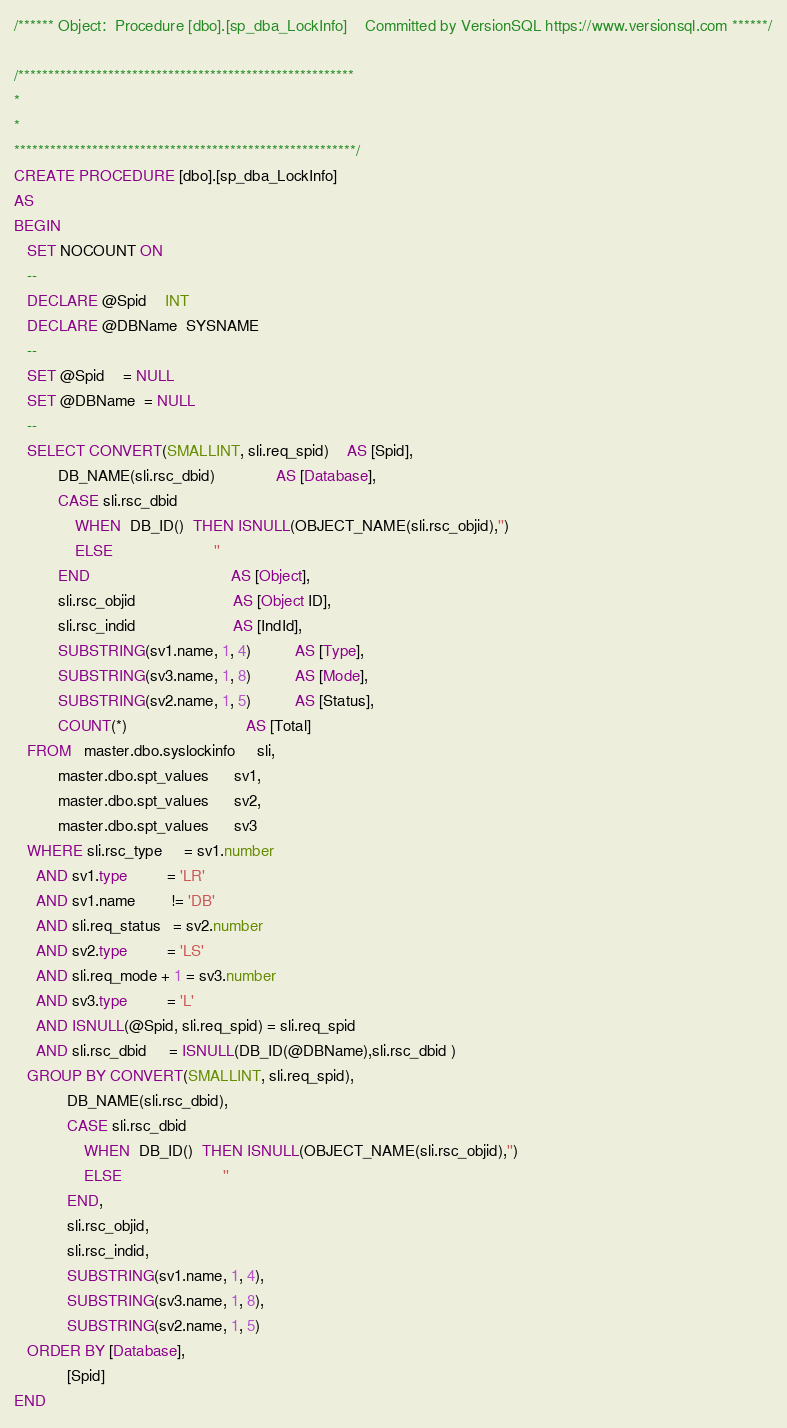Convert code to text. <code><loc_0><loc_0><loc_500><loc_500><_SQL_>/****** Object:  Procedure [dbo].[sp_dba_LockInfo]    Committed by VersionSQL https://www.versionsql.com ******/

/********************************************************
*
*
*********************************************************/
CREATE PROCEDURE [dbo].[sp_dba_LockInfo]
AS
BEGIN
   SET NOCOUNT ON
   --
   DECLARE @Spid    INT
   DECLARE @DBName  SYSNAME
   --
   SET @Spid    = NULL
   SET @DBName  = NULL
   -- 
   SELECT CONVERT(SMALLINT, sli.req_spid)    AS [Spid],
          DB_NAME(sli.rsc_dbid)              AS [Database],
          CASE sli.rsc_dbid
              WHEN  DB_ID()  THEN ISNULL(OBJECT_NAME(sli.rsc_objid),'')
              ELSE                       ''
          END                                AS [Object],
          sli.rsc_objid                      AS [Object ID],
          sli.rsc_indid                      AS [IndId],
          SUBSTRING(sv1.name, 1, 4)          AS [Type],
          SUBSTRING(sv3.name, 1, 8)          AS [Mode],
          SUBSTRING(sv2.name, 1, 5)          AS [Status],
          COUNT(*)                           AS [Total]
   FROM   master.dbo.syslockinfo     sli,
          master.dbo.spt_values      sv1,
          master.dbo.spt_values      sv2,
          master.dbo.spt_values      sv3
   WHERE sli.rsc_type     = sv1.number
     AND sv1.type         = 'LR'
     AND sv1.name        != 'DB'
     AND sli.req_status   = sv2.number
     AND sv2.type         = 'LS'
     AND sli.req_mode + 1 = sv3.number
     AND sv3.type         = 'L'
     AND ISNULL(@Spid, sli.req_spid) = sli.req_spid
     AND sli.rsc_dbid     = ISNULL(DB_ID(@DBName),sli.rsc_dbid )
   GROUP BY CONVERT(SMALLINT, sli.req_spid),
            DB_NAME(sli.rsc_dbid),
            CASE sli.rsc_dbid
                WHEN  DB_ID()  THEN ISNULL(OBJECT_NAME(sli.rsc_objid),'')
                ELSE                       ''
            END,
            sli.rsc_objid,
            sli.rsc_indid,
            SUBSTRING(sv1.name, 1, 4),
            SUBSTRING(sv3.name, 1, 8),
            SUBSTRING(sv2.name, 1, 5)
   ORDER BY [Database],
            [Spid]
END
</code> 